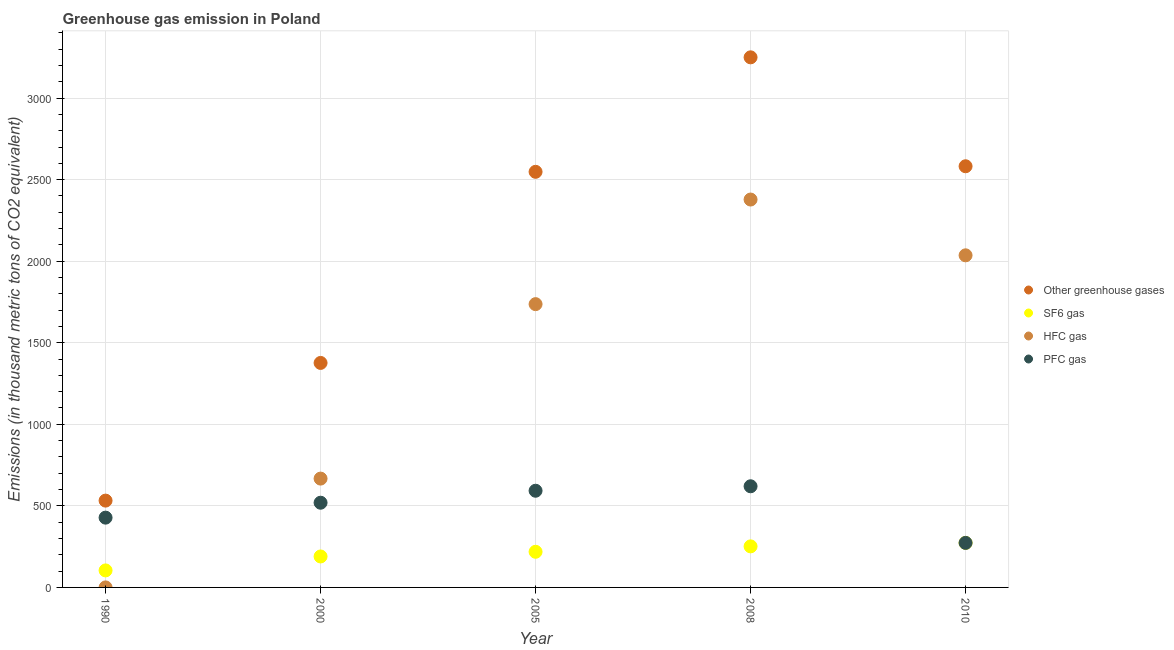What is the emission of greenhouse gases in 2000?
Provide a short and direct response. 1376.3. Across all years, what is the maximum emission of sf6 gas?
Offer a terse response. 273. Across all years, what is the minimum emission of sf6 gas?
Provide a succinct answer. 104.3. In which year was the emission of greenhouse gases minimum?
Offer a very short reply. 1990. What is the total emission of sf6 gas in the graph?
Your answer should be very brief. 1037.3. What is the difference between the emission of greenhouse gases in 1990 and that in 2005?
Offer a terse response. -2015.7. What is the difference between the emission of hfc gas in 2010 and the emission of greenhouse gases in 1990?
Your answer should be compact. 1503.8. What is the average emission of greenhouse gases per year?
Ensure brevity in your answer.  2057.64. In the year 1990, what is the difference between the emission of hfc gas and emission of greenhouse gases?
Your answer should be compact. -532.1. In how many years, is the emission of sf6 gas greater than 2800 thousand metric tons?
Your answer should be very brief. 0. What is the ratio of the emission of hfc gas in 2000 to that in 2010?
Your response must be concise. 0.33. What is the difference between the highest and the second highest emission of hfc gas?
Provide a short and direct response. 342. What is the difference between the highest and the lowest emission of greenhouse gases?
Offer a terse response. 2717.6. Is the sum of the emission of greenhouse gases in 2005 and 2010 greater than the maximum emission of sf6 gas across all years?
Provide a succinct answer. Yes. Is it the case that in every year, the sum of the emission of pfc gas and emission of greenhouse gases is greater than the sum of emission of sf6 gas and emission of hfc gas?
Offer a terse response. Yes. Is it the case that in every year, the sum of the emission of greenhouse gases and emission of sf6 gas is greater than the emission of hfc gas?
Give a very brief answer. Yes. Is the emission of sf6 gas strictly less than the emission of hfc gas over the years?
Keep it short and to the point. No. What is the difference between two consecutive major ticks on the Y-axis?
Give a very brief answer. 500. Are the values on the major ticks of Y-axis written in scientific E-notation?
Provide a short and direct response. No. Where does the legend appear in the graph?
Offer a very short reply. Center right. How many legend labels are there?
Ensure brevity in your answer.  4. How are the legend labels stacked?
Offer a very short reply. Vertical. What is the title of the graph?
Offer a terse response. Greenhouse gas emission in Poland. Does "Methodology assessment" appear as one of the legend labels in the graph?
Your response must be concise. No. What is the label or title of the X-axis?
Offer a very short reply. Year. What is the label or title of the Y-axis?
Give a very brief answer. Emissions (in thousand metric tons of CO2 equivalent). What is the Emissions (in thousand metric tons of CO2 equivalent) of Other greenhouse gases in 1990?
Keep it short and to the point. 532.2. What is the Emissions (in thousand metric tons of CO2 equivalent) in SF6 gas in 1990?
Provide a succinct answer. 104.3. What is the Emissions (in thousand metric tons of CO2 equivalent) in HFC gas in 1990?
Offer a terse response. 0.1. What is the Emissions (in thousand metric tons of CO2 equivalent) in PFC gas in 1990?
Give a very brief answer. 427.8. What is the Emissions (in thousand metric tons of CO2 equivalent) in Other greenhouse gases in 2000?
Your response must be concise. 1376.3. What is the Emissions (in thousand metric tons of CO2 equivalent) of SF6 gas in 2000?
Provide a short and direct response. 189.8. What is the Emissions (in thousand metric tons of CO2 equivalent) of HFC gas in 2000?
Provide a short and direct response. 667.2. What is the Emissions (in thousand metric tons of CO2 equivalent) in PFC gas in 2000?
Provide a short and direct response. 519.3. What is the Emissions (in thousand metric tons of CO2 equivalent) in Other greenhouse gases in 2005?
Offer a terse response. 2547.9. What is the Emissions (in thousand metric tons of CO2 equivalent) of SF6 gas in 2005?
Your response must be concise. 218.5. What is the Emissions (in thousand metric tons of CO2 equivalent) in HFC gas in 2005?
Your answer should be very brief. 1736.7. What is the Emissions (in thousand metric tons of CO2 equivalent) of PFC gas in 2005?
Offer a terse response. 592.7. What is the Emissions (in thousand metric tons of CO2 equivalent) of Other greenhouse gases in 2008?
Offer a very short reply. 3249.8. What is the Emissions (in thousand metric tons of CO2 equivalent) in SF6 gas in 2008?
Offer a terse response. 251.7. What is the Emissions (in thousand metric tons of CO2 equivalent) of HFC gas in 2008?
Ensure brevity in your answer.  2378. What is the Emissions (in thousand metric tons of CO2 equivalent) of PFC gas in 2008?
Provide a short and direct response. 620.1. What is the Emissions (in thousand metric tons of CO2 equivalent) of Other greenhouse gases in 2010?
Offer a very short reply. 2582. What is the Emissions (in thousand metric tons of CO2 equivalent) in SF6 gas in 2010?
Your answer should be compact. 273. What is the Emissions (in thousand metric tons of CO2 equivalent) in HFC gas in 2010?
Make the answer very short. 2036. What is the Emissions (in thousand metric tons of CO2 equivalent) of PFC gas in 2010?
Provide a succinct answer. 273. Across all years, what is the maximum Emissions (in thousand metric tons of CO2 equivalent) in Other greenhouse gases?
Make the answer very short. 3249.8. Across all years, what is the maximum Emissions (in thousand metric tons of CO2 equivalent) in SF6 gas?
Offer a terse response. 273. Across all years, what is the maximum Emissions (in thousand metric tons of CO2 equivalent) of HFC gas?
Make the answer very short. 2378. Across all years, what is the maximum Emissions (in thousand metric tons of CO2 equivalent) in PFC gas?
Your answer should be very brief. 620.1. Across all years, what is the minimum Emissions (in thousand metric tons of CO2 equivalent) in Other greenhouse gases?
Provide a succinct answer. 532.2. Across all years, what is the minimum Emissions (in thousand metric tons of CO2 equivalent) of SF6 gas?
Provide a succinct answer. 104.3. Across all years, what is the minimum Emissions (in thousand metric tons of CO2 equivalent) of PFC gas?
Give a very brief answer. 273. What is the total Emissions (in thousand metric tons of CO2 equivalent) in Other greenhouse gases in the graph?
Ensure brevity in your answer.  1.03e+04. What is the total Emissions (in thousand metric tons of CO2 equivalent) in SF6 gas in the graph?
Your answer should be very brief. 1037.3. What is the total Emissions (in thousand metric tons of CO2 equivalent) of HFC gas in the graph?
Offer a very short reply. 6818. What is the total Emissions (in thousand metric tons of CO2 equivalent) in PFC gas in the graph?
Offer a terse response. 2432.9. What is the difference between the Emissions (in thousand metric tons of CO2 equivalent) in Other greenhouse gases in 1990 and that in 2000?
Provide a succinct answer. -844.1. What is the difference between the Emissions (in thousand metric tons of CO2 equivalent) of SF6 gas in 1990 and that in 2000?
Give a very brief answer. -85.5. What is the difference between the Emissions (in thousand metric tons of CO2 equivalent) in HFC gas in 1990 and that in 2000?
Make the answer very short. -667.1. What is the difference between the Emissions (in thousand metric tons of CO2 equivalent) in PFC gas in 1990 and that in 2000?
Offer a terse response. -91.5. What is the difference between the Emissions (in thousand metric tons of CO2 equivalent) in Other greenhouse gases in 1990 and that in 2005?
Provide a succinct answer. -2015.7. What is the difference between the Emissions (in thousand metric tons of CO2 equivalent) of SF6 gas in 1990 and that in 2005?
Provide a short and direct response. -114.2. What is the difference between the Emissions (in thousand metric tons of CO2 equivalent) of HFC gas in 1990 and that in 2005?
Your response must be concise. -1736.6. What is the difference between the Emissions (in thousand metric tons of CO2 equivalent) of PFC gas in 1990 and that in 2005?
Offer a very short reply. -164.9. What is the difference between the Emissions (in thousand metric tons of CO2 equivalent) of Other greenhouse gases in 1990 and that in 2008?
Your response must be concise. -2717.6. What is the difference between the Emissions (in thousand metric tons of CO2 equivalent) of SF6 gas in 1990 and that in 2008?
Your answer should be very brief. -147.4. What is the difference between the Emissions (in thousand metric tons of CO2 equivalent) of HFC gas in 1990 and that in 2008?
Offer a terse response. -2377.9. What is the difference between the Emissions (in thousand metric tons of CO2 equivalent) of PFC gas in 1990 and that in 2008?
Your answer should be very brief. -192.3. What is the difference between the Emissions (in thousand metric tons of CO2 equivalent) of Other greenhouse gases in 1990 and that in 2010?
Offer a very short reply. -2049.8. What is the difference between the Emissions (in thousand metric tons of CO2 equivalent) in SF6 gas in 1990 and that in 2010?
Give a very brief answer. -168.7. What is the difference between the Emissions (in thousand metric tons of CO2 equivalent) in HFC gas in 1990 and that in 2010?
Keep it short and to the point. -2035.9. What is the difference between the Emissions (in thousand metric tons of CO2 equivalent) of PFC gas in 1990 and that in 2010?
Your answer should be very brief. 154.8. What is the difference between the Emissions (in thousand metric tons of CO2 equivalent) in Other greenhouse gases in 2000 and that in 2005?
Offer a terse response. -1171.6. What is the difference between the Emissions (in thousand metric tons of CO2 equivalent) of SF6 gas in 2000 and that in 2005?
Ensure brevity in your answer.  -28.7. What is the difference between the Emissions (in thousand metric tons of CO2 equivalent) in HFC gas in 2000 and that in 2005?
Give a very brief answer. -1069.5. What is the difference between the Emissions (in thousand metric tons of CO2 equivalent) of PFC gas in 2000 and that in 2005?
Provide a succinct answer. -73.4. What is the difference between the Emissions (in thousand metric tons of CO2 equivalent) in Other greenhouse gases in 2000 and that in 2008?
Your response must be concise. -1873.5. What is the difference between the Emissions (in thousand metric tons of CO2 equivalent) in SF6 gas in 2000 and that in 2008?
Make the answer very short. -61.9. What is the difference between the Emissions (in thousand metric tons of CO2 equivalent) of HFC gas in 2000 and that in 2008?
Offer a terse response. -1710.8. What is the difference between the Emissions (in thousand metric tons of CO2 equivalent) of PFC gas in 2000 and that in 2008?
Provide a short and direct response. -100.8. What is the difference between the Emissions (in thousand metric tons of CO2 equivalent) of Other greenhouse gases in 2000 and that in 2010?
Your response must be concise. -1205.7. What is the difference between the Emissions (in thousand metric tons of CO2 equivalent) in SF6 gas in 2000 and that in 2010?
Provide a succinct answer. -83.2. What is the difference between the Emissions (in thousand metric tons of CO2 equivalent) of HFC gas in 2000 and that in 2010?
Your answer should be compact. -1368.8. What is the difference between the Emissions (in thousand metric tons of CO2 equivalent) in PFC gas in 2000 and that in 2010?
Offer a very short reply. 246.3. What is the difference between the Emissions (in thousand metric tons of CO2 equivalent) in Other greenhouse gases in 2005 and that in 2008?
Offer a very short reply. -701.9. What is the difference between the Emissions (in thousand metric tons of CO2 equivalent) in SF6 gas in 2005 and that in 2008?
Provide a short and direct response. -33.2. What is the difference between the Emissions (in thousand metric tons of CO2 equivalent) in HFC gas in 2005 and that in 2008?
Provide a short and direct response. -641.3. What is the difference between the Emissions (in thousand metric tons of CO2 equivalent) of PFC gas in 2005 and that in 2008?
Give a very brief answer. -27.4. What is the difference between the Emissions (in thousand metric tons of CO2 equivalent) of Other greenhouse gases in 2005 and that in 2010?
Keep it short and to the point. -34.1. What is the difference between the Emissions (in thousand metric tons of CO2 equivalent) of SF6 gas in 2005 and that in 2010?
Your answer should be compact. -54.5. What is the difference between the Emissions (in thousand metric tons of CO2 equivalent) of HFC gas in 2005 and that in 2010?
Your answer should be very brief. -299.3. What is the difference between the Emissions (in thousand metric tons of CO2 equivalent) in PFC gas in 2005 and that in 2010?
Your response must be concise. 319.7. What is the difference between the Emissions (in thousand metric tons of CO2 equivalent) in Other greenhouse gases in 2008 and that in 2010?
Offer a very short reply. 667.8. What is the difference between the Emissions (in thousand metric tons of CO2 equivalent) in SF6 gas in 2008 and that in 2010?
Ensure brevity in your answer.  -21.3. What is the difference between the Emissions (in thousand metric tons of CO2 equivalent) of HFC gas in 2008 and that in 2010?
Give a very brief answer. 342. What is the difference between the Emissions (in thousand metric tons of CO2 equivalent) in PFC gas in 2008 and that in 2010?
Keep it short and to the point. 347.1. What is the difference between the Emissions (in thousand metric tons of CO2 equivalent) of Other greenhouse gases in 1990 and the Emissions (in thousand metric tons of CO2 equivalent) of SF6 gas in 2000?
Give a very brief answer. 342.4. What is the difference between the Emissions (in thousand metric tons of CO2 equivalent) in Other greenhouse gases in 1990 and the Emissions (in thousand metric tons of CO2 equivalent) in HFC gas in 2000?
Offer a terse response. -135. What is the difference between the Emissions (in thousand metric tons of CO2 equivalent) in Other greenhouse gases in 1990 and the Emissions (in thousand metric tons of CO2 equivalent) in PFC gas in 2000?
Keep it short and to the point. 12.9. What is the difference between the Emissions (in thousand metric tons of CO2 equivalent) of SF6 gas in 1990 and the Emissions (in thousand metric tons of CO2 equivalent) of HFC gas in 2000?
Make the answer very short. -562.9. What is the difference between the Emissions (in thousand metric tons of CO2 equivalent) of SF6 gas in 1990 and the Emissions (in thousand metric tons of CO2 equivalent) of PFC gas in 2000?
Offer a terse response. -415. What is the difference between the Emissions (in thousand metric tons of CO2 equivalent) in HFC gas in 1990 and the Emissions (in thousand metric tons of CO2 equivalent) in PFC gas in 2000?
Your answer should be compact. -519.2. What is the difference between the Emissions (in thousand metric tons of CO2 equivalent) in Other greenhouse gases in 1990 and the Emissions (in thousand metric tons of CO2 equivalent) in SF6 gas in 2005?
Offer a terse response. 313.7. What is the difference between the Emissions (in thousand metric tons of CO2 equivalent) in Other greenhouse gases in 1990 and the Emissions (in thousand metric tons of CO2 equivalent) in HFC gas in 2005?
Provide a succinct answer. -1204.5. What is the difference between the Emissions (in thousand metric tons of CO2 equivalent) in Other greenhouse gases in 1990 and the Emissions (in thousand metric tons of CO2 equivalent) in PFC gas in 2005?
Your answer should be very brief. -60.5. What is the difference between the Emissions (in thousand metric tons of CO2 equivalent) in SF6 gas in 1990 and the Emissions (in thousand metric tons of CO2 equivalent) in HFC gas in 2005?
Your answer should be very brief. -1632.4. What is the difference between the Emissions (in thousand metric tons of CO2 equivalent) in SF6 gas in 1990 and the Emissions (in thousand metric tons of CO2 equivalent) in PFC gas in 2005?
Give a very brief answer. -488.4. What is the difference between the Emissions (in thousand metric tons of CO2 equivalent) of HFC gas in 1990 and the Emissions (in thousand metric tons of CO2 equivalent) of PFC gas in 2005?
Your answer should be compact. -592.6. What is the difference between the Emissions (in thousand metric tons of CO2 equivalent) in Other greenhouse gases in 1990 and the Emissions (in thousand metric tons of CO2 equivalent) in SF6 gas in 2008?
Your response must be concise. 280.5. What is the difference between the Emissions (in thousand metric tons of CO2 equivalent) in Other greenhouse gases in 1990 and the Emissions (in thousand metric tons of CO2 equivalent) in HFC gas in 2008?
Your answer should be compact. -1845.8. What is the difference between the Emissions (in thousand metric tons of CO2 equivalent) in Other greenhouse gases in 1990 and the Emissions (in thousand metric tons of CO2 equivalent) in PFC gas in 2008?
Your answer should be very brief. -87.9. What is the difference between the Emissions (in thousand metric tons of CO2 equivalent) in SF6 gas in 1990 and the Emissions (in thousand metric tons of CO2 equivalent) in HFC gas in 2008?
Give a very brief answer. -2273.7. What is the difference between the Emissions (in thousand metric tons of CO2 equivalent) of SF6 gas in 1990 and the Emissions (in thousand metric tons of CO2 equivalent) of PFC gas in 2008?
Your answer should be compact. -515.8. What is the difference between the Emissions (in thousand metric tons of CO2 equivalent) in HFC gas in 1990 and the Emissions (in thousand metric tons of CO2 equivalent) in PFC gas in 2008?
Your response must be concise. -620. What is the difference between the Emissions (in thousand metric tons of CO2 equivalent) of Other greenhouse gases in 1990 and the Emissions (in thousand metric tons of CO2 equivalent) of SF6 gas in 2010?
Offer a very short reply. 259.2. What is the difference between the Emissions (in thousand metric tons of CO2 equivalent) in Other greenhouse gases in 1990 and the Emissions (in thousand metric tons of CO2 equivalent) in HFC gas in 2010?
Offer a terse response. -1503.8. What is the difference between the Emissions (in thousand metric tons of CO2 equivalent) of Other greenhouse gases in 1990 and the Emissions (in thousand metric tons of CO2 equivalent) of PFC gas in 2010?
Your answer should be compact. 259.2. What is the difference between the Emissions (in thousand metric tons of CO2 equivalent) of SF6 gas in 1990 and the Emissions (in thousand metric tons of CO2 equivalent) of HFC gas in 2010?
Keep it short and to the point. -1931.7. What is the difference between the Emissions (in thousand metric tons of CO2 equivalent) of SF6 gas in 1990 and the Emissions (in thousand metric tons of CO2 equivalent) of PFC gas in 2010?
Ensure brevity in your answer.  -168.7. What is the difference between the Emissions (in thousand metric tons of CO2 equivalent) of HFC gas in 1990 and the Emissions (in thousand metric tons of CO2 equivalent) of PFC gas in 2010?
Your answer should be very brief. -272.9. What is the difference between the Emissions (in thousand metric tons of CO2 equivalent) of Other greenhouse gases in 2000 and the Emissions (in thousand metric tons of CO2 equivalent) of SF6 gas in 2005?
Provide a short and direct response. 1157.8. What is the difference between the Emissions (in thousand metric tons of CO2 equivalent) in Other greenhouse gases in 2000 and the Emissions (in thousand metric tons of CO2 equivalent) in HFC gas in 2005?
Offer a terse response. -360.4. What is the difference between the Emissions (in thousand metric tons of CO2 equivalent) of Other greenhouse gases in 2000 and the Emissions (in thousand metric tons of CO2 equivalent) of PFC gas in 2005?
Keep it short and to the point. 783.6. What is the difference between the Emissions (in thousand metric tons of CO2 equivalent) of SF6 gas in 2000 and the Emissions (in thousand metric tons of CO2 equivalent) of HFC gas in 2005?
Make the answer very short. -1546.9. What is the difference between the Emissions (in thousand metric tons of CO2 equivalent) in SF6 gas in 2000 and the Emissions (in thousand metric tons of CO2 equivalent) in PFC gas in 2005?
Make the answer very short. -402.9. What is the difference between the Emissions (in thousand metric tons of CO2 equivalent) in HFC gas in 2000 and the Emissions (in thousand metric tons of CO2 equivalent) in PFC gas in 2005?
Your answer should be compact. 74.5. What is the difference between the Emissions (in thousand metric tons of CO2 equivalent) in Other greenhouse gases in 2000 and the Emissions (in thousand metric tons of CO2 equivalent) in SF6 gas in 2008?
Keep it short and to the point. 1124.6. What is the difference between the Emissions (in thousand metric tons of CO2 equivalent) in Other greenhouse gases in 2000 and the Emissions (in thousand metric tons of CO2 equivalent) in HFC gas in 2008?
Make the answer very short. -1001.7. What is the difference between the Emissions (in thousand metric tons of CO2 equivalent) in Other greenhouse gases in 2000 and the Emissions (in thousand metric tons of CO2 equivalent) in PFC gas in 2008?
Your answer should be very brief. 756.2. What is the difference between the Emissions (in thousand metric tons of CO2 equivalent) in SF6 gas in 2000 and the Emissions (in thousand metric tons of CO2 equivalent) in HFC gas in 2008?
Your answer should be very brief. -2188.2. What is the difference between the Emissions (in thousand metric tons of CO2 equivalent) of SF6 gas in 2000 and the Emissions (in thousand metric tons of CO2 equivalent) of PFC gas in 2008?
Offer a very short reply. -430.3. What is the difference between the Emissions (in thousand metric tons of CO2 equivalent) in HFC gas in 2000 and the Emissions (in thousand metric tons of CO2 equivalent) in PFC gas in 2008?
Offer a terse response. 47.1. What is the difference between the Emissions (in thousand metric tons of CO2 equivalent) of Other greenhouse gases in 2000 and the Emissions (in thousand metric tons of CO2 equivalent) of SF6 gas in 2010?
Make the answer very short. 1103.3. What is the difference between the Emissions (in thousand metric tons of CO2 equivalent) of Other greenhouse gases in 2000 and the Emissions (in thousand metric tons of CO2 equivalent) of HFC gas in 2010?
Your answer should be very brief. -659.7. What is the difference between the Emissions (in thousand metric tons of CO2 equivalent) of Other greenhouse gases in 2000 and the Emissions (in thousand metric tons of CO2 equivalent) of PFC gas in 2010?
Give a very brief answer. 1103.3. What is the difference between the Emissions (in thousand metric tons of CO2 equivalent) of SF6 gas in 2000 and the Emissions (in thousand metric tons of CO2 equivalent) of HFC gas in 2010?
Offer a terse response. -1846.2. What is the difference between the Emissions (in thousand metric tons of CO2 equivalent) of SF6 gas in 2000 and the Emissions (in thousand metric tons of CO2 equivalent) of PFC gas in 2010?
Offer a very short reply. -83.2. What is the difference between the Emissions (in thousand metric tons of CO2 equivalent) of HFC gas in 2000 and the Emissions (in thousand metric tons of CO2 equivalent) of PFC gas in 2010?
Ensure brevity in your answer.  394.2. What is the difference between the Emissions (in thousand metric tons of CO2 equivalent) of Other greenhouse gases in 2005 and the Emissions (in thousand metric tons of CO2 equivalent) of SF6 gas in 2008?
Your answer should be very brief. 2296.2. What is the difference between the Emissions (in thousand metric tons of CO2 equivalent) of Other greenhouse gases in 2005 and the Emissions (in thousand metric tons of CO2 equivalent) of HFC gas in 2008?
Your answer should be compact. 169.9. What is the difference between the Emissions (in thousand metric tons of CO2 equivalent) of Other greenhouse gases in 2005 and the Emissions (in thousand metric tons of CO2 equivalent) of PFC gas in 2008?
Provide a succinct answer. 1927.8. What is the difference between the Emissions (in thousand metric tons of CO2 equivalent) of SF6 gas in 2005 and the Emissions (in thousand metric tons of CO2 equivalent) of HFC gas in 2008?
Offer a terse response. -2159.5. What is the difference between the Emissions (in thousand metric tons of CO2 equivalent) of SF6 gas in 2005 and the Emissions (in thousand metric tons of CO2 equivalent) of PFC gas in 2008?
Your answer should be very brief. -401.6. What is the difference between the Emissions (in thousand metric tons of CO2 equivalent) of HFC gas in 2005 and the Emissions (in thousand metric tons of CO2 equivalent) of PFC gas in 2008?
Offer a terse response. 1116.6. What is the difference between the Emissions (in thousand metric tons of CO2 equivalent) of Other greenhouse gases in 2005 and the Emissions (in thousand metric tons of CO2 equivalent) of SF6 gas in 2010?
Ensure brevity in your answer.  2274.9. What is the difference between the Emissions (in thousand metric tons of CO2 equivalent) of Other greenhouse gases in 2005 and the Emissions (in thousand metric tons of CO2 equivalent) of HFC gas in 2010?
Offer a terse response. 511.9. What is the difference between the Emissions (in thousand metric tons of CO2 equivalent) of Other greenhouse gases in 2005 and the Emissions (in thousand metric tons of CO2 equivalent) of PFC gas in 2010?
Offer a very short reply. 2274.9. What is the difference between the Emissions (in thousand metric tons of CO2 equivalent) in SF6 gas in 2005 and the Emissions (in thousand metric tons of CO2 equivalent) in HFC gas in 2010?
Make the answer very short. -1817.5. What is the difference between the Emissions (in thousand metric tons of CO2 equivalent) of SF6 gas in 2005 and the Emissions (in thousand metric tons of CO2 equivalent) of PFC gas in 2010?
Your answer should be compact. -54.5. What is the difference between the Emissions (in thousand metric tons of CO2 equivalent) in HFC gas in 2005 and the Emissions (in thousand metric tons of CO2 equivalent) in PFC gas in 2010?
Your answer should be compact. 1463.7. What is the difference between the Emissions (in thousand metric tons of CO2 equivalent) of Other greenhouse gases in 2008 and the Emissions (in thousand metric tons of CO2 equivalent) of SF6 gas in 2010?
Your answer should be very brief. 2976.8. What is the difference between the Emissions (in thousand metric tons of CO2 equivalent) of Other greenhouse gases in 2008 and the Emissions (in thousand metric tons of CO2 equivalent) of HFC gas in 2010?
Your answer should be very brief. 1213.8. What is the difference between the Emissions (in thousand metric tons of CO2 equivalent) in Other greenhouse gases in 2008 and the Emissions (in thousand metric tons of CO2 equivalent) in PFC gas in 2010?
Ensure brevity in your answer.  2976.8. What is the difference between the Emissions (in thousand metric tons of CO2 equivalent) in SF6 gas in 2008 and the Emissions (in thousand metric tons of CO2 equivalent) in HFC gas in 2010?
Make the answer very short. -1784.3. What is the difference between the Emissions (in thousand metric tons of CO2 equivalent) in SF6 gas in 2008 and the Emissions (in thousand metric tons of CO2 equivalent) in PFC gas in 2010?
Provide a short and direct response. -21.3. What is the difference between the Emissions (in thousand metric tons of CO2 equivalent) in HFC gas in 2008 and the Emissions (in thousand metric tons of CO2 equivalent) in PFC gas in 2010?
Your response must be concise. 2105. What is the average Emissions (in thousand metric tons of CO2 equivalent) of Other greenhouse gases per year?
Ensure brevity in your answer.  2057.64. What is the average Emissions (in thousand metric tons of CO2 equivalent) in SF6 gas per year?
Offer a very short reply. 207.46. What is the average Emissions (in thousand metric tons of CO2 equivalent) in HFC gas per year?
Your answer should be compact. 1363.6. What is the average Emissions (in thousand metric tons of CO2 equivalent) in PFC gas per year?
Provide a short and direct response. 486.58. In the year 1990, what is the difference between the Emissions (in thousand metric tons of CO2 equivalent) of Other greenhouse gases and Emissions (in thousand metric tons of CO2 equivalent) of SF6 gas?
Provide a short and direct response. 427.9. In the year 1990, what is the difference between the Emissions (in thousand metric tons of CO2 equivalent) in Other greenhouse gases and Emissions (in thousand metric tons of CO2 equivalent) in HFC gas?
Provide a succinct answer. 532.1. In the year 1990, what is the difference between the Emissions (in thousand metric tons of CO2 equivalent) of Other greenhouse gases and Emissions (in thousand metric tons of CO2 equivalent) of PFC gas?
Give a very brief answer. 104.4. In the year 1990, what is the difference between the Emissions (in thousand metric tons of CO2 equivalent) of SF6 gas and Emissions (in thousand metric tons of CO2 equivalent) of HFC gas?
Provide a short and direct response. 104.2. In the year 1990, what is the difference between the Emissions (in thousand metric tons of CO2 equivalent) in SF6 gas and Emissions (in thousand metric tons of CO2 equivalent) in PFC gas?
Ensure brevity in your answer.  -323.5. In the year 1990, what is the difference between the Emissions (in thousand metric tons of CO2 equivalent) in HFC gas and Emissions (in thousand metric tons of CO2 equivalent) in PFC gas?
Make the answer very short. -427.7. In the year 2000, what is the difference between the Emissions (in thousand metric tons of CO2 equivalent) of Other greenhouse gases and Emissions (in thousand metric tons of CO2 equivalent) of SF6 gas?
Your answer should be very brief. 1186.5. In the year 2000, what is the difference between the Emissions (in thousand metric tons of CO2 equivalent) in Other greenhouse gases and Emissions (in thousand metric tons of CO2 equivalent) in HFC gas?
Provide a succinct answer. 709.1. In the year 2000, what is the difference between the Emissions (in thousand metric tons of CO2 equivalent) in Other greenhouse gases and Emissions (in thousand metric tons of CO2 equivalent) in PFC gas?
Provide a succinct answer. 857. In the year 2000, what is the difference between the Emissions (in thousand metric tons of CO2 equivalent) of SF6 gas and Emissions (in thousand metric tons of CO2 equivalent) of HFC gas?
Make the answer very short. -477.4. In the year 2000, what is the difference between the Emissions (in thousand metric tons of CO2 equivalent) of SF6 gas and Emissions (in thousand metric tons of CO2 equivalent) of PFC gas?
Make the answer very short. -329.5. In the year 2000, what is the difference between the Emissions (in thousand metric tons of CO2 equivalent) of HFC gas and Emissions (in thousand metric tons of CO2 equivalent) of PFC gas?
Ensure brevity in your answer.  147.9. In the year 2005, what is the difference between the Emissions (in thousand metric tons of CO2 equivalent) in Other greenhouse gases and Emissions (in thousand metric tons of CO2 equivalent) in SF6 gas?
Your answer should be very brief. 2329.4. In the year 2005, what is the difference between the Emissions (in thousand metric tons of CO2 equivalent) in Other greenhouse gases and Emissions (in thousand metric tons of CO2 equivalent) in HFC gas?
Offer a terse response. 811.2. In the year 2005, what is the difference between the Emissions (in thousand metric tons of CO2 equivalent) in Other greenhouse gases and Emissions (in thousand metric tons of CO2 equivalent) in PFC gas?
Give a very brief answer. 1955.2. In the year 2005, what is the difference between the Emissions (in thousand metric tons of CO2 equivalent) of SF6 gas and Emissions (in thousand metric tons of CO2 equivalent) of HFC gas?
Your response must be concise. -1518.2. In the year 2005, what is the difference between the Emissions (in thousand metric tons of CO2 equivalent) in SF6 gas and Emissions (in thousand metric tons of CO2 equivalent) in PFC gas?
Your answer should be very brief. -374.2. In the year 2005, what is the difference between the Emissions (in thousand metric tons of CO2 equivalent) of HFC gas and Emissions (in thousand metric tons of CO2 equivalent) of PFC gas?
Offer a terse response. 1144. In the year 2008, what is the difference between the Emissions (in thousand metric tons of CO2 equivalent) in Other greenhouse gases and Emissions (in thousand metric tons of CO2 equivalent) in SF6 gas?
Provide a succinct answer. 2998.1. In the year 2008, what is the difference between the Emissions (in thousand metric tons of CO2 equivalent) in Other greenhouse gases and Emissions (in thousand metric tons of CO2 equivalent) in HFC gas?
Provide a short and direct response. 871.8. In the year 2008, what is the difference between the Emissions (in thousand metric tons of CO2 equivalent) in Other greenhouse gases and Emissions (in thousand metric tons of CO2 equivalent) in PFC gas?
Your answer should be compact. 2629.7. In the year 2008, what is the difference between the Emissions (in thousand metric tons of CO2 equivalent) in SF6 gas and Emissions (in thousand metric tons of CO2 equivalent) in HFC gas?
Your answer should be compact. -2126.3. In the year 2008, what is the difference between the Emissions (in thousand metric tons of CO2 equivalent) in SF6 gas and Emissions (in thousand metric tons of CO2 equivalent) in PFC gas?
Your answer should be very brief. -368.4. In the year 2008, what is the difference between the Emissions (in thousand metric tons of CO2 equivalent) of HFC gas and Emissions (in thousand metric tons of CO2 equivalent) of PFC gas?
Provide a succinct answer. 1757.9. In the year 2010, what is the difference between the Emissions (in thousand metric tons of CO2 equivalent) of Other greenhouse gases and Emissions (in thousand metric tons of CO2 equivalent) of SF6 gas?
Your answer should be very brief. 2309. In the year 2010, what is the difference between the Emissions (in thousand metric tons of CO2 equivalent) in Other greenhouse gases and Emissions (in thousand metric tons of CO2 equivalent) in HFC gas?
Offer a terse response. 546. In the year 2010, what is the difference between the Emissions (in thousand metric tons of CO2 equivalent) in Other greenhouse gases and Emissions (in thousand metric tons of CO2 equivalent) in PFC gas?
Your response must be concise. 2309. In the year 2010, what is the difference between the Emissions (in thousand metric tons of CO2 equivalent) in SF6 gas and Emissions (in thousand metric tons of CO2 equivalent) in HFC gas?
Provide a succinct answer. -1763. In the year 2010, what is the difference between the Emissions (in thousand metric tons of CO2 equivalent) of SF6 gas and Emissions (in thousand metric tons of CO2 equivalent) of PFC gas?
Your answer should be very brief. 0. In the year 2010, what is the difference between the Emissions (in thousand metric tons of CO2 equivalent) of HFC gas and Emissions (in thousand metric tons of CO2 equivalent) of PFC gas?
Keep it short and to the point. 1763. What is the ratio of the Emissions (in thousand metric tons of CO2 equivalent) of Other greenhouse gases in 1990 to that in 2000?
Provide a succinct answer. 0.39. What is the ratio of the Emissions (in thousand metric tons of CO2 equivalent) of SF6 gas in 1990 to that in 2000?
Your answer should be very brief. 0.55. What is the ratio of the Emissions (in thousand metric tons of CO2 equivalent) of PFC gas in 1990 to that in 2000?
Make the answer very short. 0.82. What is the ratio of the Emissions (in thousand metric tons of CO2 equivalent) of Other greenhouse gases in 1990 to that in 2005?
Offer a terse response. 0.21. What is the ratio of the Emissions (in thousand metric tons of CO2 equivalent) in SF6 gas in 1990 to that in 2005?
Offer a terse response. 0.48. What is the ratio of the Emissions (in thousand metric tons of CO2 equivalent) in PFC gas in 1990 to that in 2005?
Your response must be concise. 0.72. What is the ratio of the Emissions (in thousand metric tons of CO2 equivalent) in Other greenhouse gases in 1990 to that in 2008?
Provide a succinct answer. 0.16. What is the ratio of the Emissions (in thousand metric tons of CO2 equivalent) of SF6 gas in 1990 to that in 2008?
Provide a succinct answer. 0.41. What is the ratio of the Emissions (in thousand metric tons of CO2 equivalent) in HFC gas in 1990 to that in 2008?
Provide a succinct answer. 0. What is the ratio of the Emissions (in thousand metric tons of CO2 equivalent) of PFC gas in 1990 to that in 2008?
Your answer should be compact. 0.69. What is the ratio of the Emissions (in thousand metric tons of CO2 equivalent) in Other greenhouse gases in 1990 to that in 2010?
Your response must be concise. 0.21. What is the ratio of the Emissions (in thousand metric tons of CO2 equivalent) in SF6 gas in 1990 to that in 2010?
Make the answer very short. 0.38. What is the ratio of the Emissions (in thousand metric tons of CO2 equivalent) in PFC gas in 1990 to that in 2010?
Your response must be concise. 1.57. What is the ratio of the Emissions (in thousand metric tons of CO2 equivalent) of Other greenhouse gases in 2000 to that in 2005?
Your answer should be very brief. 0.54. What is the ratio of the Emissions (in thousand metric tons of CO2 equivalent) in SF6 gas in 2000 to that in 2005?
Ensure brevity in your answer.  0.87. What is the ratio of the Emissions (in thousand metric tons of CO2 equivalent) of HFC gas in 2000 to that in 2005?
Offer a very short reply. 0.38. What is the ratio of the Emissions (in thousand metric tons of CO2 equivalent) in PFC gas in 2000 to that in 2005?
Your answer should be very brief. 0.88. What is the ratio of the Emissions (in thousand metric tons of CO2 equivalent) in Other greenhouse gases in 2000 to that in 2008?
Ensure brevity in your answer.  0.42. What is the ratio of the Emissions (in thousand metric tons of CO2 equivalent) in SF6 gas in 2000 to that in 2008?
Provide a succinct answer. 0.75. What is the ratio of the Emissions (in thousand metric tons of CO2 equivalent) of HFC gas in 2000 to that in 2008?
Keep it short and to the point. 0.28. What is the ratio of the Emissions (in thousand metric tons of CO2 equivalent) in PFC gas in 2000 to that in 2008?
Your answer should be compact. 0.84. What is the ratio of the Emissions (in thousand metric tons of CO2 equivalent) of Other greenhouse gases in 2000 to that in 2010?
Provide a succinct answer. 0.53. What is the ratio of the Emissions (in thousand metric tons of CO2 equivalent) of SF6 gas in 2000 to that in 2010?
Offer a terse response. 0.7. What is the ratio of the Emissions (in thousand metric tons of CO2 equivalent) of HFC gas in 2000 to that in 2010?
Keep it short and to the point. 0.33. What is the ratio of the Emissions (in thousand metric tons of CO2 equivalent) of PFC gas in 2000 to that in 2010?
Your answer should be compact. 1.9. What is the ratio of the Emissions (in thousand metric tons of CO2 equivalent) of Other greenhouse gases in 2005 to that in 2008?
Make the answer very short. 0.78. What is the ratio of the Emissions (in thousand metric tons of CO2 equivalent) of SF6 gas in 2005 to that in 2008?
Your answer should be compact. 0.87. What is the ratio of the Emissions (in thousand metric tons of CO2 equivalent) of HFC gas in 2005 to that in 2008?
Offer a terse response. 0.73. What is the ratio of the Emissions (in thousand metric tons of CO2 equivalent) in PFC gas in 2005 to that in 2008?
Your response must be concise. 0.96. What is the ratio of the Emissions (in thousand metric tons of CO2 equivalent) in Other greenhouse gases in 2005 to that in 2010?
Your answer should be compact. 0.99. What is the ratio of the Emissions (in thousand metric tons of CO2 equivalent) in SF6 gas in 2005 to that in 2010?
Offer a terse response. 0.8. What is the ratio of the Emissions (in thousand metric tons of CO2 equivalent) of HFC gas in 2005 to that in 2010?
Your response must be concise. 0.85. What is the ratio of the Emissions (in thousand metric tons of CO2 equivalent) of PFC gas in 2005 to that in 2010?
Offer a terse response. 2.17. What is the ratio of the Emissions (in thousand metric tons of CO2 equivalent) of Other greenhouse gases in 2008 to that in 2010?
Make the answer very short. 1.26. What is the ratio of the Emissions (in thousand metric tons of CO2 equivalent) of SF6 gas in 2008 to that in 2010?
Your answer should be very brief. 0.92. What is the ratio of the Emissions (in thousand metric tons of CO2 equivalent) in HFC gas in 2008 to that in 2010?
Keep it short and to the point. 1.17. What is the ratio of the Emissions (in thousand metric tons of CO2 equivalent) of PFC gas in 2008 to that in 2010?
Offer a very short reply. 2.27. What is the difference between the highest and the second highest Emissions (in thousand metric tons of CO2 equivalent) in Other greenhouse gases?
Your answer should be compact. 667.8. What is the difference between the highest and the second highest Emissions (in thousand metric tons of CO2 equivalent) of SF6 gas?
Make the answer very short. 21.3. What is the difference between the highest and the second highest Emissions (in thousand metric tons of CO2 equivalent) of HFC gas?
Provide a short and direct response. 342. What is the difference between the highest and the second highest Emissions (in thousand metric tons of CO2 equivalent) in PFC gas?
Offer a terse response. 27.4. What is the difference between the highest and the lowest Emissions (in thousand metric tons of CO2 equivalent) in Other greenhouse gases?
Offer a very short reply. 2717.6. What is the difference between the highest and the lowest Emissions (in thousand metric tons of CO2 equivalent) of SF6 gas?
Keep it short and to the point. 168.7. What is the difference between the highest and the lowest Emissions (in thousand metric tons of CO2 equivalent) of HFC gas?
Your answer should be compact. 2377.9. What is the difference between the highest and the lowest Emissions (in thousand metric tons of CO2 equivalent) in PFC gas?
Provide a short and direct response. 347.1. 